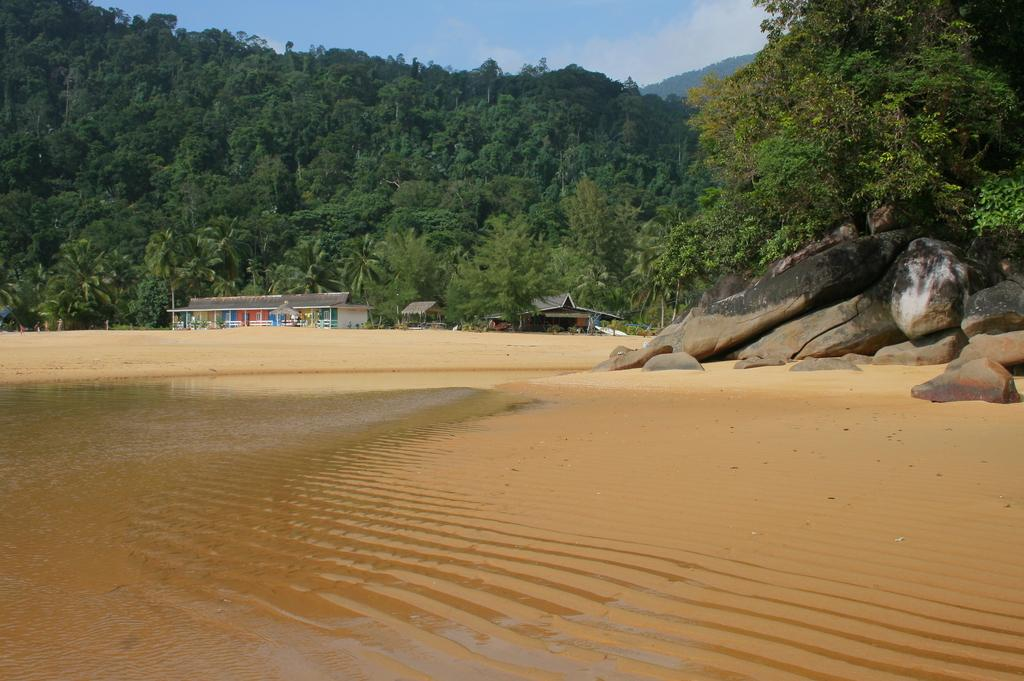What is the primary element visible in the image? There is water in the image. What can be seen on the right side of the image? There are rocks on the right side of the image. What type of vegetation is present in the image? There are trees in the image. What is visible at the top of the image? The sky is visible at the top of the image. Where is the chair located in the image? There is no chair present in the image. What type of wave can be seen in the water? There is no wave visible in the water; it is a still body of water. 